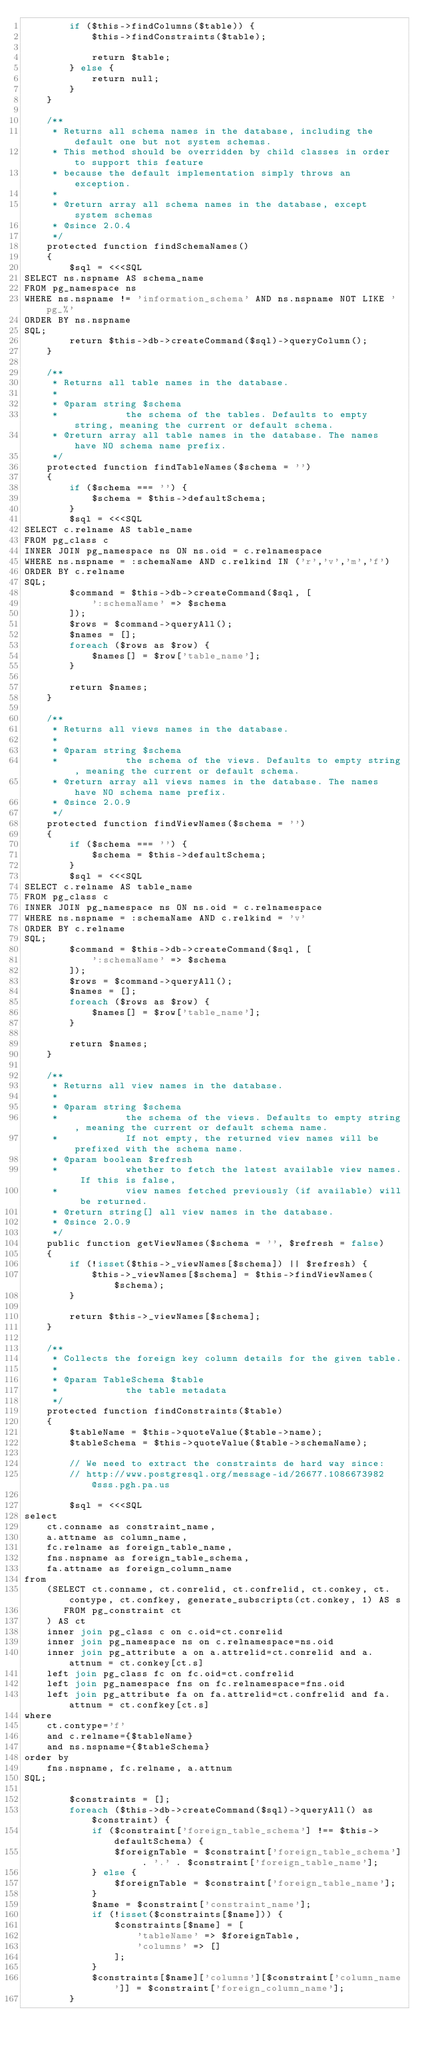<code> <loc_0><loc_0><loc_500><loc_500><_PHP_>        if ($this->findColumns($table)) {
            $this->findConstraints($table);
            
            return $table;
        } else {
            return null;
        }
    }

    /**
     * Returns all schema names in the database, including the default one but not system schemas.
     * This method should be overridden by child classes in order to support this feature
     * because the default implementation simply throws an exception.
     * 
     * @return array all schema names in the database, except system schemas
     * @since 2.0.4
     */
    protected function findSchemaNames()
    {
        $sql = <<<SQL
SELECT ns.nspname AS schema_name
FROM pg_namespace ns
WHERE ns.nspname != 'information_schema' AND ns.nspname NOT LIKE 'pg_%'
ORDER BY ns.nspname
SQL;
        return $this->db->createCommand($sql)->queryColumn();
    }

    /**
     * Returns all table names in the database.
     * 
     * @param string $schema
     *            the schema of the tables. Defaults to empty string, meaning the current or default schema.
     * @return array all table names in the database. The names have NO schema name prefix.
     */
    protected function findTableNames($schema = '')
    {
        if ($schema === '') {
            $schema = $this->defaultSchema;
        }
        $sql = <<<SQL
SELECT c.relname AS table_name
FROM pg_class c
INNER JOIN pg_namespace ns ON ns.oid = c.relnamespace
WHERE ns.nspname = :schemaName AND c.relkind IN ('r','v','m','f')
ORDER BY c.relname
SQL;
        $command = $this->db->createCommand($sql, [
            ':schemaName' => $schema
        ]);
        $rows = $command->queryAll();
        $names = [];
        foreach ($rows as $row) {
            $names[] = $row['table_name'];
        }
        
        return $names;
    }

    /**
     * Returns all views names in the database.
     * 
     * @param string $schema
     *            the schema of the views. Defaults to empty string, meaning the current or default schema.
     * @return array all views names in the database. The names have NO schema name prefix.
     * @since 2.0.9
     */
    protected function findViewNames($schema = '')
    {
        if ($schema === '') {
            $schema = $this->defaultSchema;
        }
        $sql = <<<SQL
SELECT c.relname AS table_name
FROM pg_class c
INNER JOIN pg_namespace ns ON ns.oid = c.relnamespace
WHERE ns.nspname = :schemaName AND c.relkind = 'v'
ORDER BY c.relname
SQL;
        $command = $this->db->createCommand($sql, [
            ':schemaName' => $schema
        ]);
        $rows = $command->queryAll();
        $names = [];
        foreach ($rows as $row) {
            $names[] = $row['table_name'];
        }
        
        return $names;
    }

    /**
     * Returns all view names in the database.
     * 
     * @param string $schema
     *            the schema of the views. Defaults to empty string, meaning the current or default schema name.
     *            If not empty, the returned view names will be prefixed with the schema name.
     * @param boolean $refresh
     *            whether to fetch the latest available view names. If this is false,
     *            view names fetched previously (if available) will be returned.
     * @return string[] all view names in the database.
     * @since 2.0.9
     */
    public function getViewNames($schema = '', $refresh = false)
    {
        if (!isset($this->_viewNames[$schema]) || $refresh) {
            $this->_viewNames[$schema] = $this->findViewNames($schema);
        }
        
        return $this->_viewNames[$schema];
    }

    /**
     * Collects the foreign key column details for the given table.
     * 
     * @param TableSchema $table
     *            the table metadata
     */
    protected function findConstraints($table)
    {
        $tableName = $this->quoteValue($table->name);
        $tableSchema = $this->quoteValue($table->schemaName);
        
        // We need to extract the constraints de hard way since:
        // http://www.postgresql.org/message-id/26677.1086673982@sss.pgh.pa.us
        
        $sql = <<<SQL
select
    ct.conname as constraint_name,
    a.attname as column_name,
    fc.relname as foreign_table_name,
    fns.nspname as foreign_table_schema,
    fa.attname as foreign_column_name
from
    (SELECT ct.conname, ct.conrelid, ct.confrelid, ct.conkey, ct.contype, ct.confkey, generate_subscripts(ct.conkey, 1) AS s
       FROM pg_constraint ct
    ) AS ct
    inner join pg_class c on c.oid=ct.conrelid
    inner join pg_namespace ns on c.relnamespace=ns.oid
    inner join pg_attribute a on a.attrelid=ct.conrelid and a.attnum = ct.conkey[ct.s]
    left join pg_class fc on fc.oid=ct.confrelid
    left join pg_namespace fns on fc.relnamespace=fns.oid
    left join pg_attribute fa on fa.attrelid=ct.confrelid and fa.attnum = ct.confkey[ct.s]
where
    ct.contype='f'
    and c.relname={$tableName}
    and ns.nspname={$tableSchema}
order by
    fns.nspname, fc.relname, a.attnum
SQL;
        
        $constraints = [];
        foreach ($this->db->createCommand($sql)->queryAll() as $constraint) {
            if ($constraint['foreign_table_schema'] !== $this->defaultSchema) {
                $foreignTable = $constraint['foreign_table_schema'] . '.' . $constraint['foreign_table_name'];
            } else {
                $foreignTable = $constraint['foreign_table_name'];
            }
            $name = $constraint['constraint_name'];
            if (!isset($constraints[$name])) {
                $constraints[$name] = [
                    'tableName' => $foreignTable,
                    'columns' => []
                ];
            }
            $constraints[$name]['columns'][$constraint['column_name']] = $constraint['foreign_column_name'];
        }</code> 